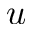<formula> <loc_0><loc_0><loc_500><loc_500>u</formula> 